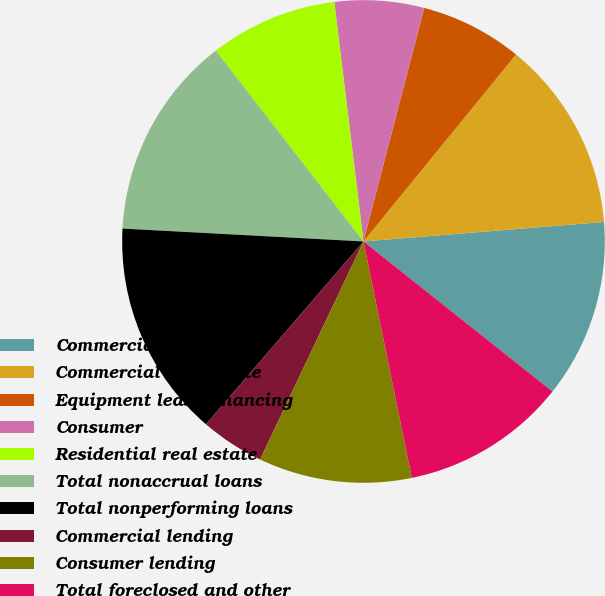Convert chart to OTSL. <chart><loc_0><loc_0><loc_500><loc_500><pie_chart><fcel>Commercial<fcel>Commercial real estate<fcel>Equipment lease financing<fcel>Consumer<fcel>Residential real estate<fcel>Total nonaccrual loans<fcel>Total nonperforming loans<fcel>Commercial lending<fcel>Consumer lending<fcel>Total foreclosed and other<nl><fcel>11.97%<fcel>12.82%<fcel>6.84%<fcel>5.98%<fcel>8.55%<fcel>13.67%<fcel>14.53%<fcel>4.27%<fcel>10.26%<fcel>11.11%<nl></chart> 